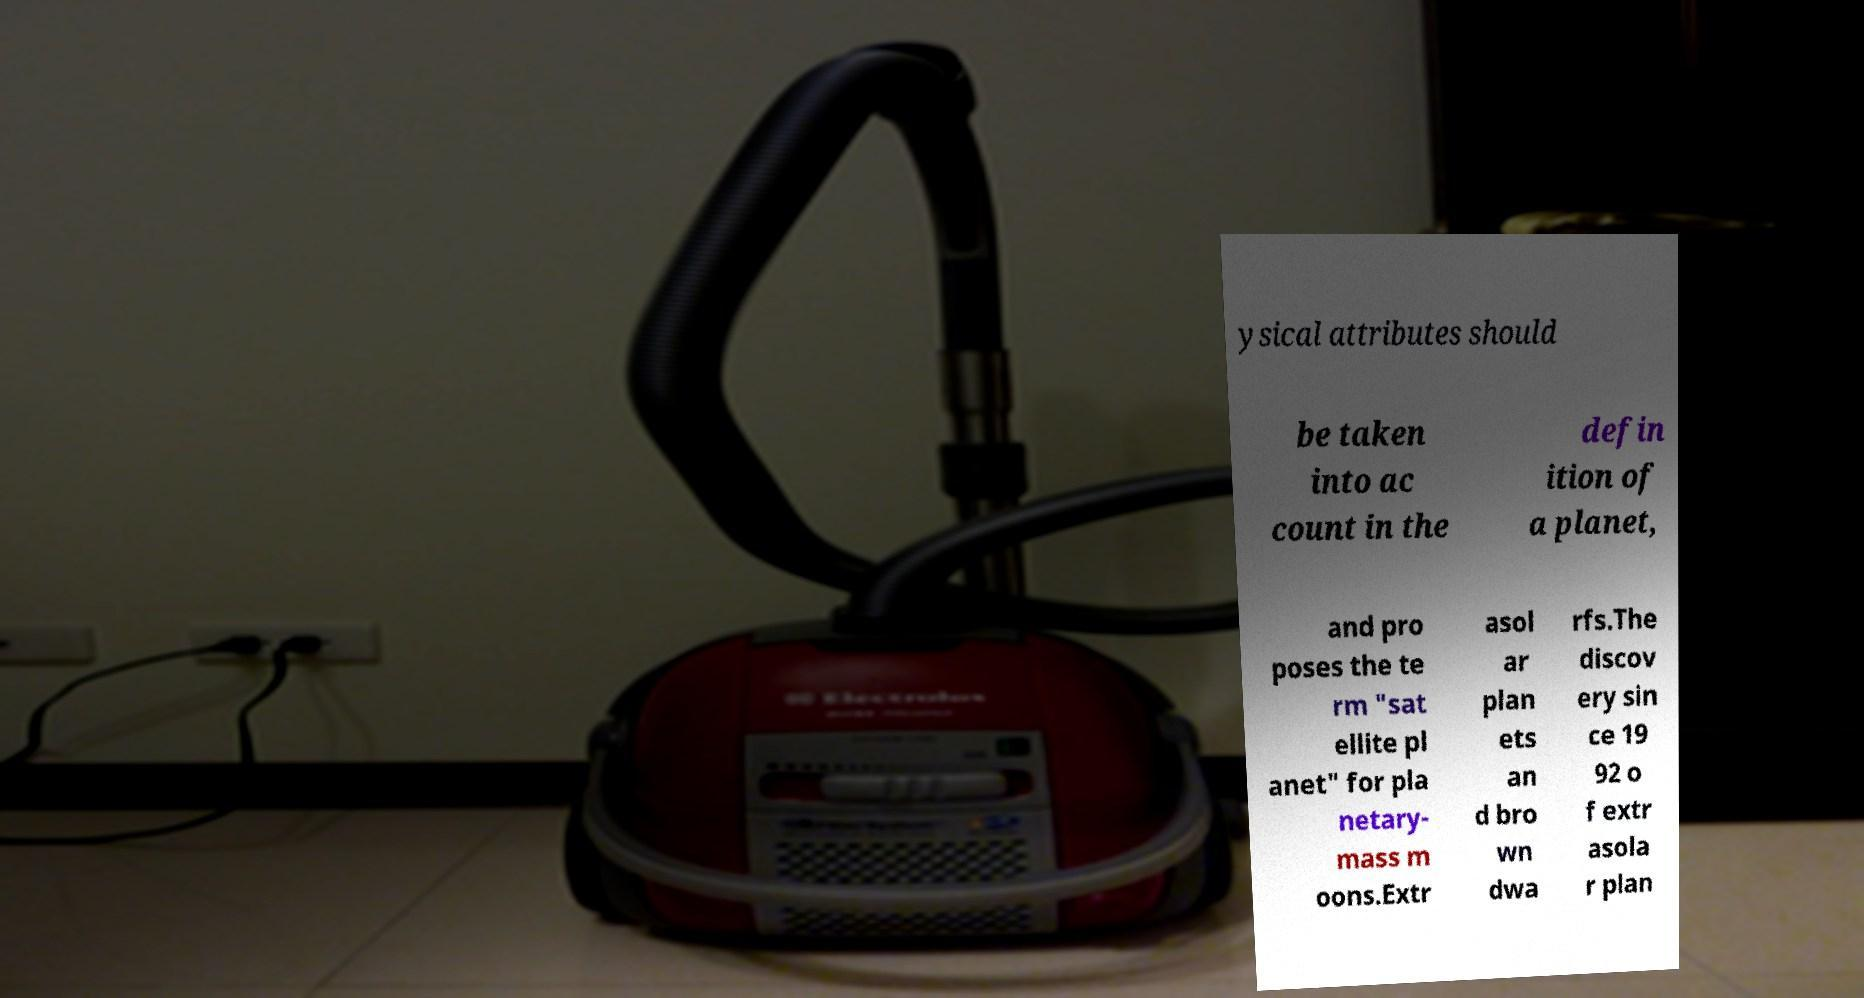Could you assist in decoding the text presented in this image and type it out clearly? ysical attributes should be taken into ac count in the defin ition of a planet, and pro poses the te rm "sat ellite pl anet" for pla netary- mass m oons.Extr asol ar plan ets an d bro wn dwa rfs.The discov ery sin ce 19 92 o f extr asola r plan 